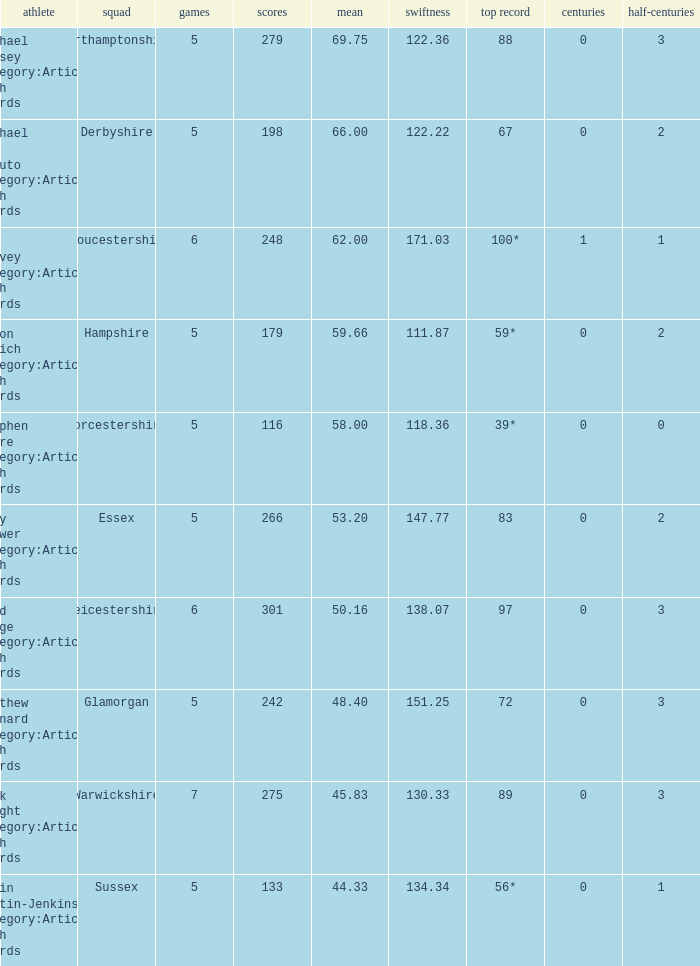Give me the full table as a dictionary. {'header': ['athlete', 'squad', 'games', 'scores', 'mean', 'swiftness', 'top record', 'centuries', 'half-centuries'], 'rows': [['Michael Hussey Category:Articles with hCards', 'Northamptonshire', '5', '279', '69.75', '122.36', '88', '0', '3'], ['Michael Di Venuto Category:Articles with hCards', 'Derbyshire', '5', '198', '66.00', '122.22', '67', '0', '2'], ['Ian Harvey Category:Articles with hCards', 'Gloucestershire', '6', '248', '62.00', '171.03', '100*', '1', '1'], ['Simon Katich Category:Articles with hCards', 'Hampshire', '5', '179', '59.66', '111.87', '59*', '0', '2'], ['Stephen Moore Category:Articles with hCards', 'Worcestershire', '5', '116', '58.00', '118.36', '39*', '0', '0'], ['Andy Flower Category:Articles with hCards', 'Essex', '5', '266', '53.20', '147.77', '83', '0', '2'], ['Brad Hodge Category:Articles with hCards', 'Leicestershire', '6', '301', '50.16', '138.07', '97', '0', '3'], ['Matthew Maynard Category:Articles with hCards', 'Glamorgan', '5', '242', '48.40', '151.25', '72', '0', '3'], ['Nick Knight Category:Articles with hCards', 'Warwickshire', '7', '275', '45.83', '130.33', '89', '0', '3'], ['Robin Martin-Jenkins Category:Articles with hCards', 'Sussex', '5', '133', '44.33', '134.34', '56*', '0', '1']]} If the team is Gloucestershire, what is the average? 62.0. 